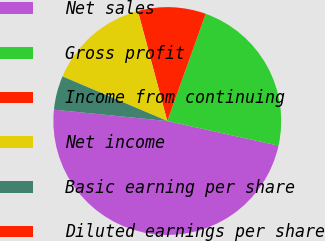Convert chart to OTSL. <chart><loc_0><loc_0><loc_500><loc_500><pie_chart><fcel>Net sales<fcel>Gross profit<fcel>Income from continuing<fcel>Net income<fcel>Basic earning per share<fcel>Diluted earnings per share<nl><fcel>48.13%<fcel>22.98%<fcel>9.63%<fcel>14.44%<fcel>4.81%<fcel>0.0%<nl></chart> 